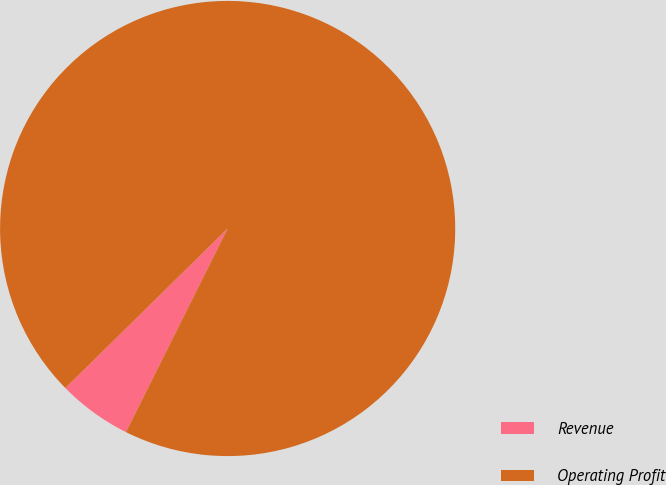Convert chart. <chart><loc_0><loc_0><loc_500><loc_500><pie_chart><fcel>Revenue<fcel>Operating Profit<nl><fcel>5.26%<fcel>94.74%<nl></chart> 